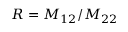<formula> <loc_0><loc_0><loc_500><loc_500>R = M _ { 1 2 } / M _ { 2 2 }</formula> 